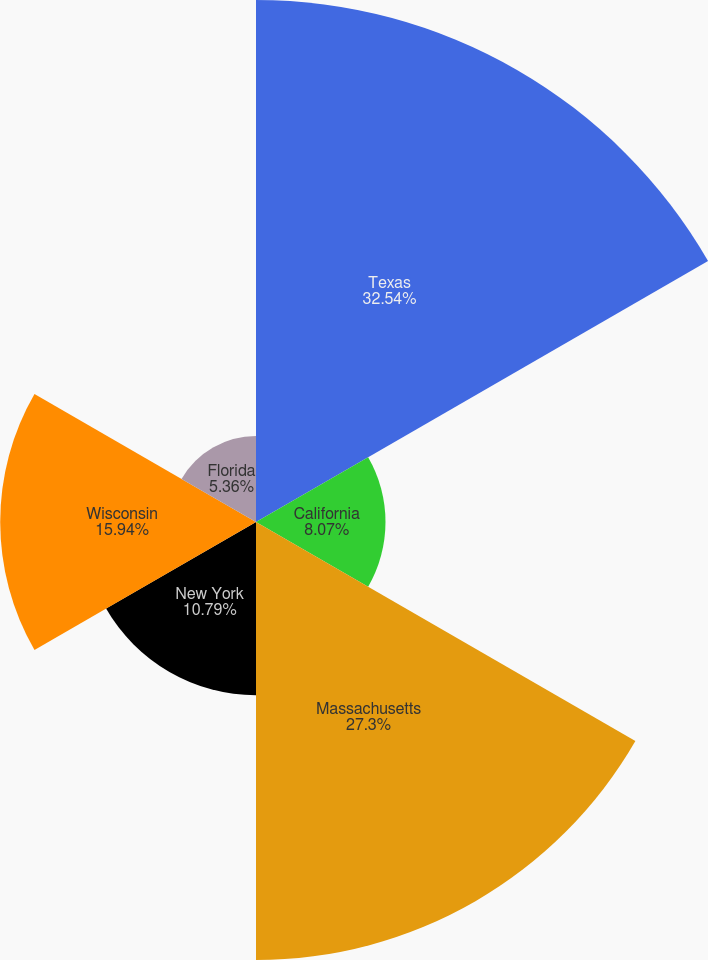Convert chart. <chart><loc_0><loc_0><loc_500><loc_500><pie_chart><fcel>Texas<fcel>California<fcel>Massachusetts<fcel>New York<fcel>Wisconsin<fcel>Florida<nl><fcel>32.53%<fcel>8.07%<fcel>27.3%<fcel>10.79%<fcel>15.94%<fcel>5.36%<nl></chart> 